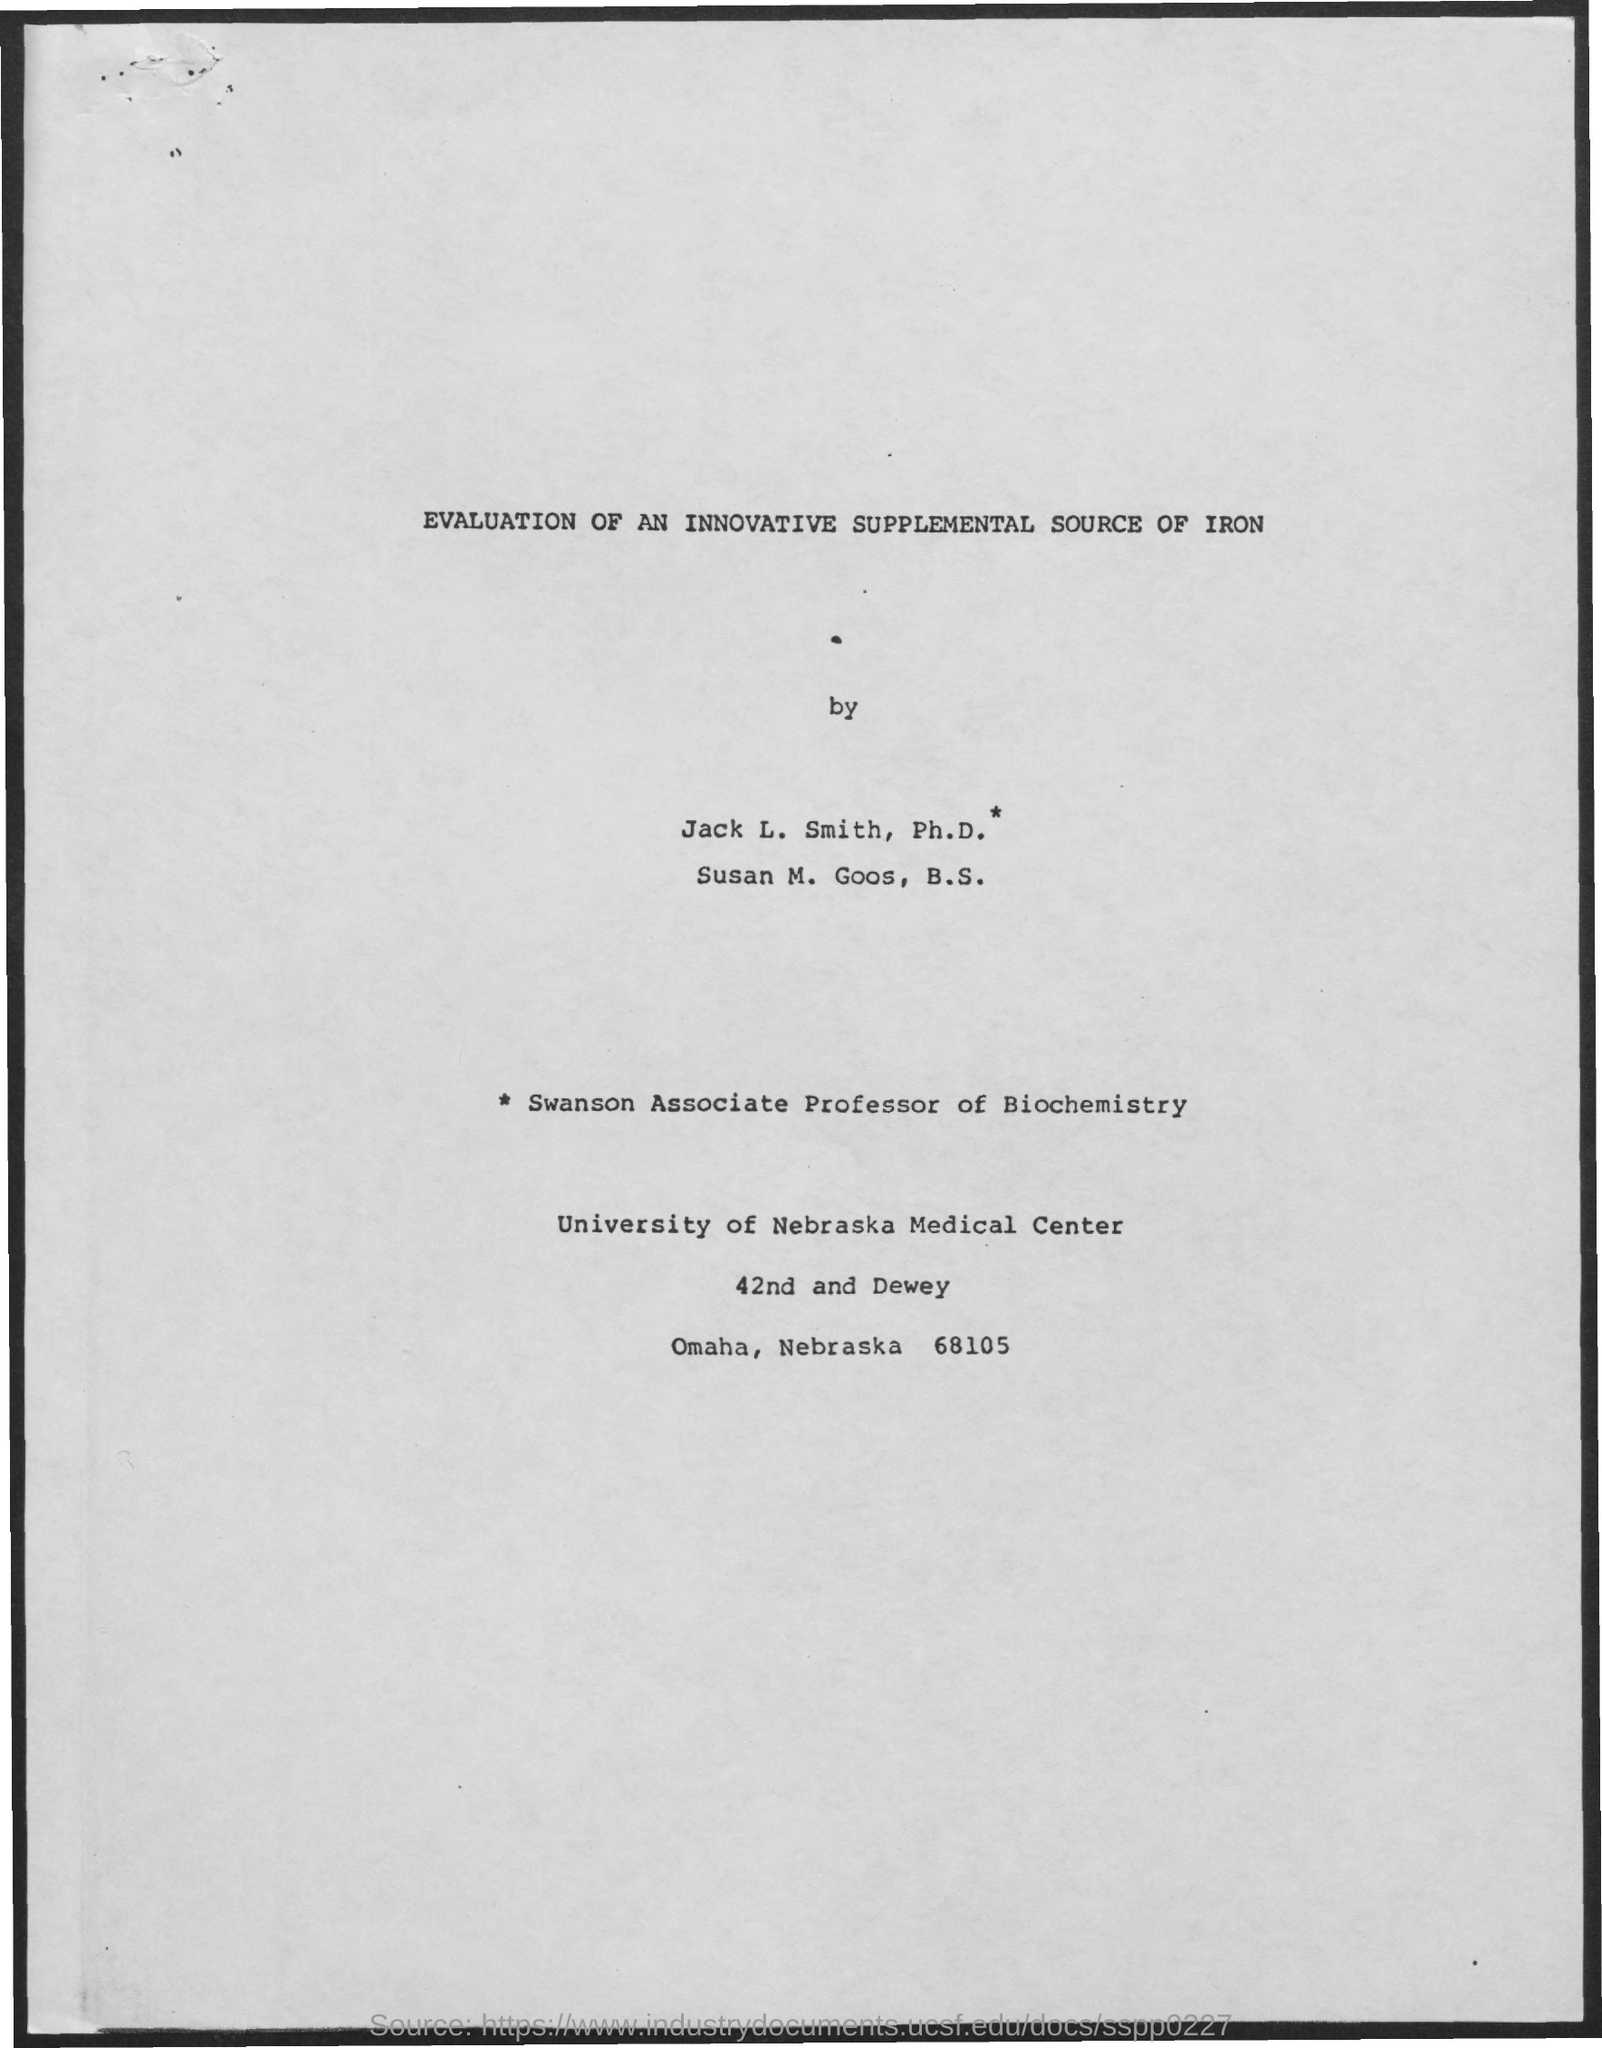What is the title of the document?
Your answer should be compact. Evaluation of an innovative supplemental source of iron. 